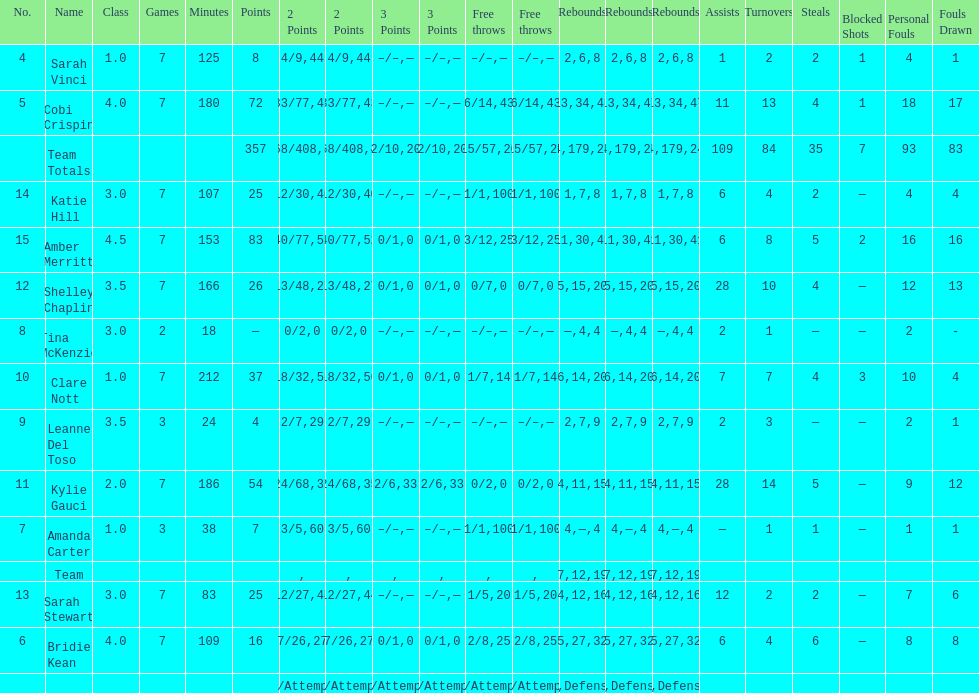Total number of assists and turnovers combined 193. 